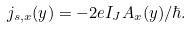Convert formula to latex. <formula><loc_0><loc_0><loc_500><loc_500>j _ { s , x } ( y ) = - 2 e I _ { J } A _ { x } ( y ) / \hbar { . }</formula> 